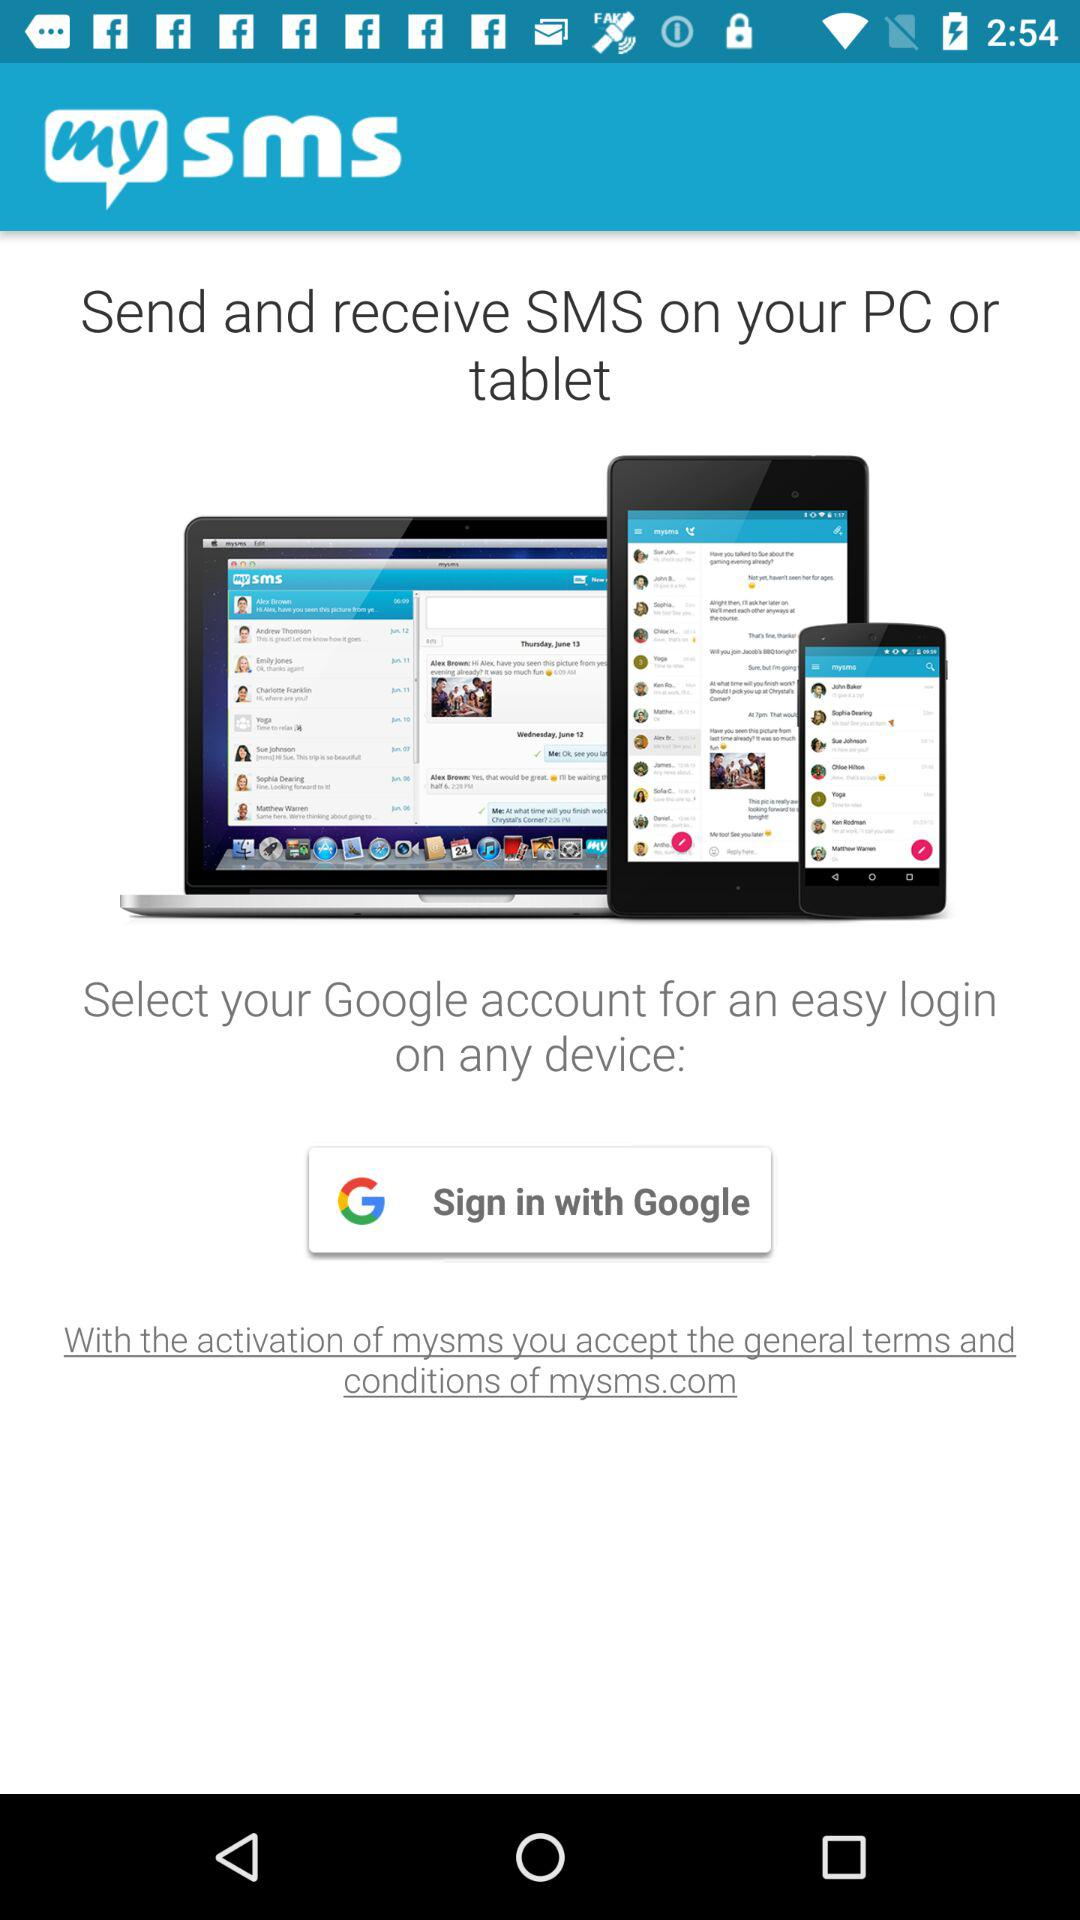What account can I use to sign in? You can sign in with "Google" account. 